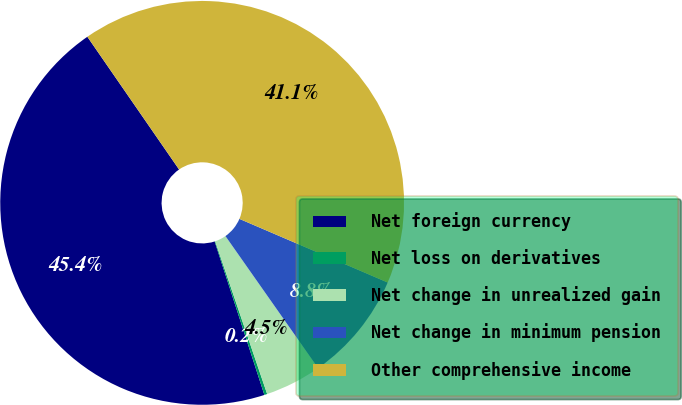<chart> <loc_0><loc_0><loc_500><loc_500><pie_chart><fcel>Net foreign currency<fcel>Net loss on derivatives<fcel>Net change in unrealized gain<fcel>Net change in minimum pension<fcel>Other comprehensive income<nl><fcel>45.37%<fcel>0.23%<fcel>4.52%<fcel>8.81%<fcel>41.08%<nl></chart> 